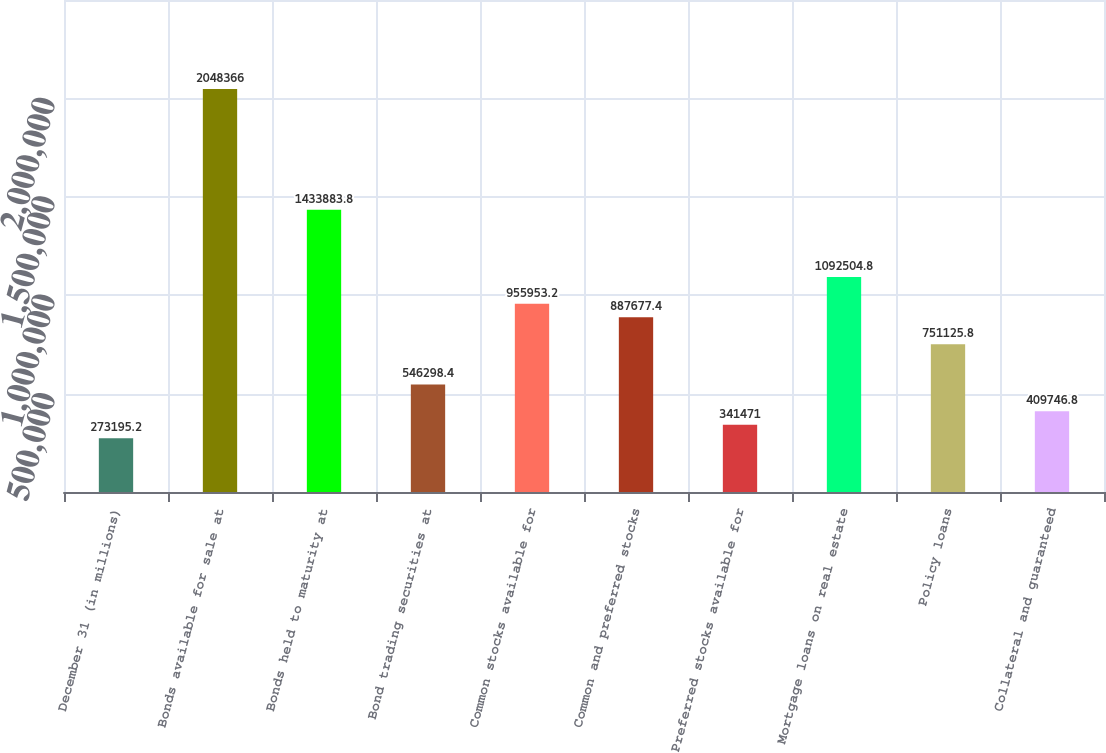<chart> <loc_0><loc_0><loc_500><loc_500><bar_chart><fcel>December 31 (in millions)<fcel>Bonds available for sale at<fcel>Bonds held to maturity at<fcel>Bond trading securities at<fcel>Common stocks available for<fcel>Common and preferred stocks<fcel>Preferred stocks available for<fcel>Mortgage loans on real estate<fcel>Policy loans<fcel>Collateral and guaranteed<nl><fcel>273195<fcel>2.04837e+06<fcel>1.43388e+06<fcel>546298<fcel>955953<fcel>887677<fcel>341471<fcel>1.0925e+06<fcel>751126<fcel>409747<nl></chart> 